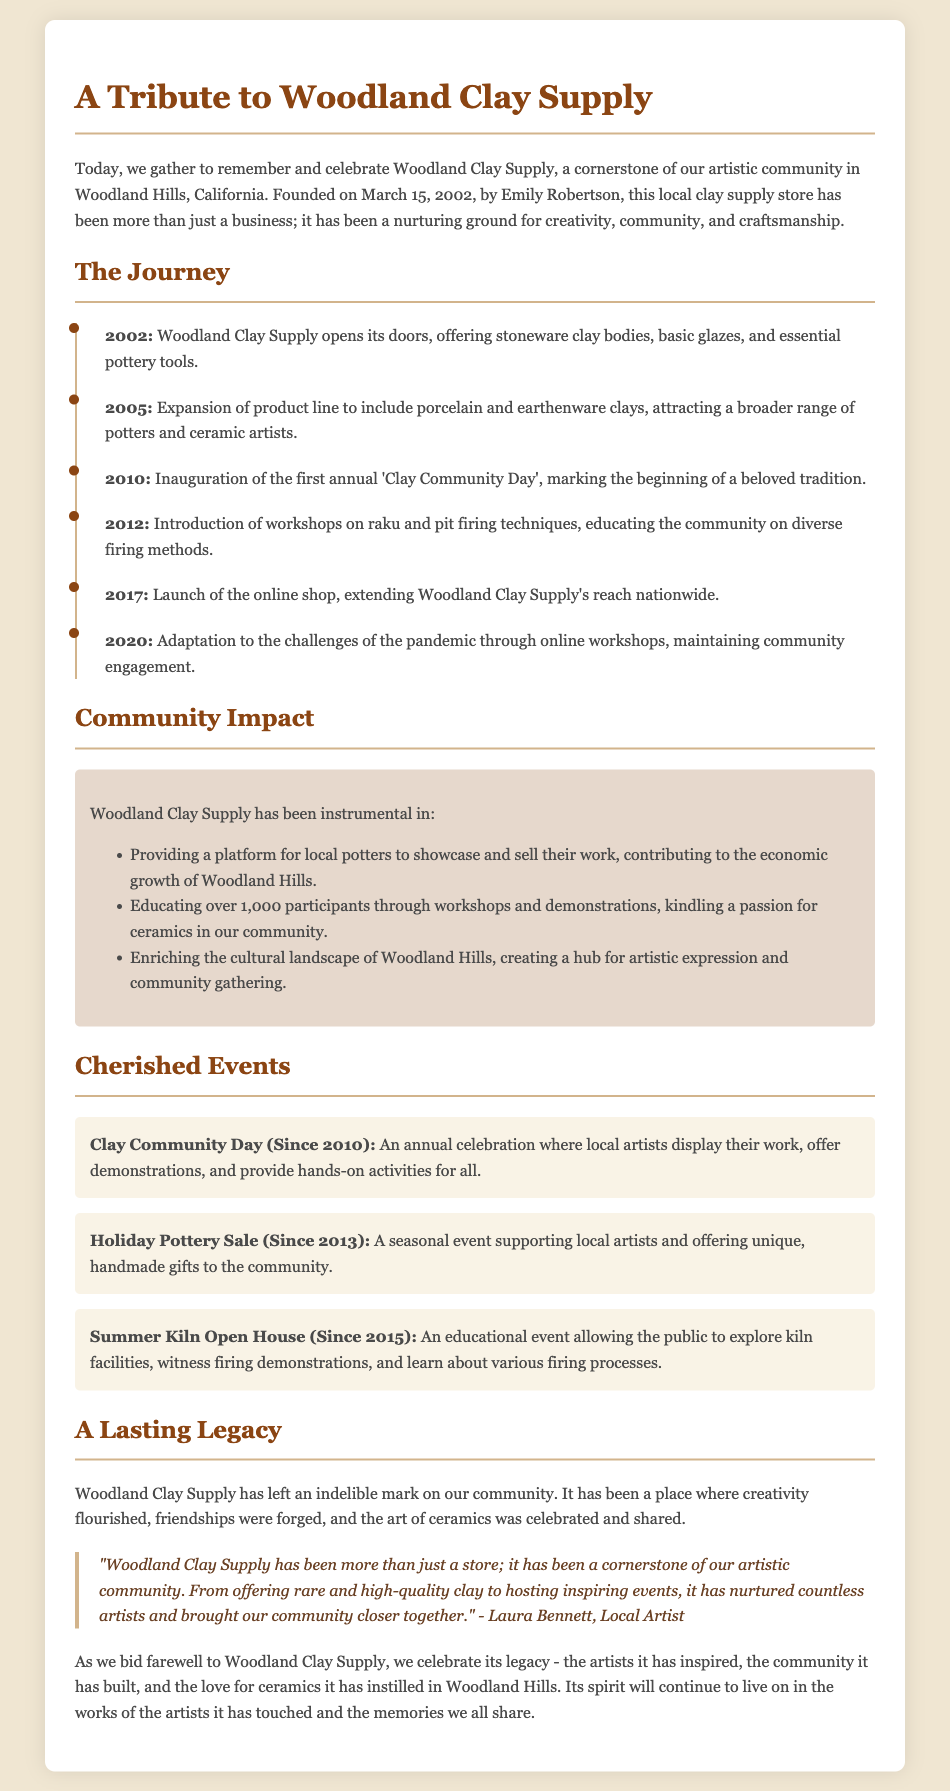What date was Woodland Clay Supply founded? The document explicitly states that Woodland Clay Supply was founded on March 15, 2002.
Answer: March 15, 2002 Who founded Woodland Clay Supply? The document mentions that Emily Robertson is the founder of Woodland Clay Supply.
Answer: Emily Robertson What year did the first annual 'Clay Community Day' take place? The document notes that the first annual 'Clay Community Day' was inaugurated in 2010.
Answer: 2010 How many participants have been educated through workshops and demonstrations? The document indicates that over 1,000 participants have been educated through workshops and demonstrations.
Answer: over 1,000 What type of clay was introduced in 2005? The document states that the product line expanded to include porcelain and earthenware clays in 2005.
Answer: porcelain and earthenware What is one of the key community events held since 2013? The document lists the Holiday Pottery Sale as a key community event that has been held since 2013.
Answer: Holiday Pottery Sale What has Woodland Clay Supply enriched in the local community? The document specifies that Woodland Clay Supply has enriched the cultural landscape of Woodland Hills.
Answer: cultural landscape Why is the quote notable in the document? The quote from Laura Bennett emphasizes the importance of Woodland Clay Supply to the artistic community, showcasing its legacy and impact.
Answer: importance to the artistic community 